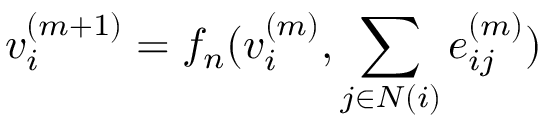<formula> <loc_0><loc_0><loc_500><loc_500>v _ { i } ^ { ( m + 1 ) } = f _ { n } ( v _ { i } ^ { ( m ) } , \sum _ { j \in N ( i ) } e _ { i j } ^ { ( m ) } )</formula> 